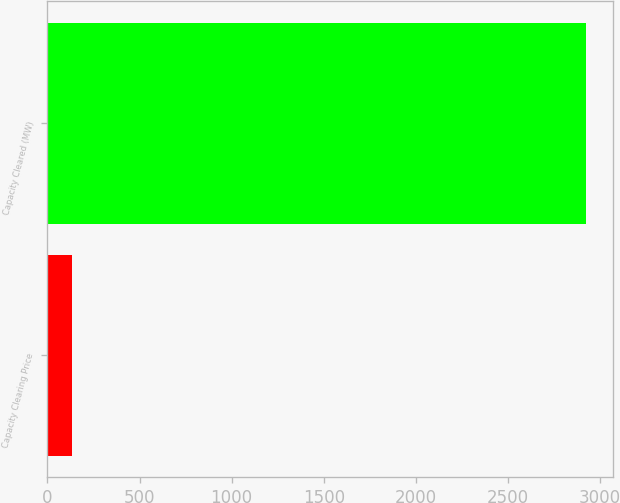Convert chart. <chart><loc_0><loc_0><loc_500><loc_500><bar_chart><fcel>Capacity Clearing Price<fcel>Capacity Cleared (MW)<nl><fcel>136<fcel>2923<nl></chart> 